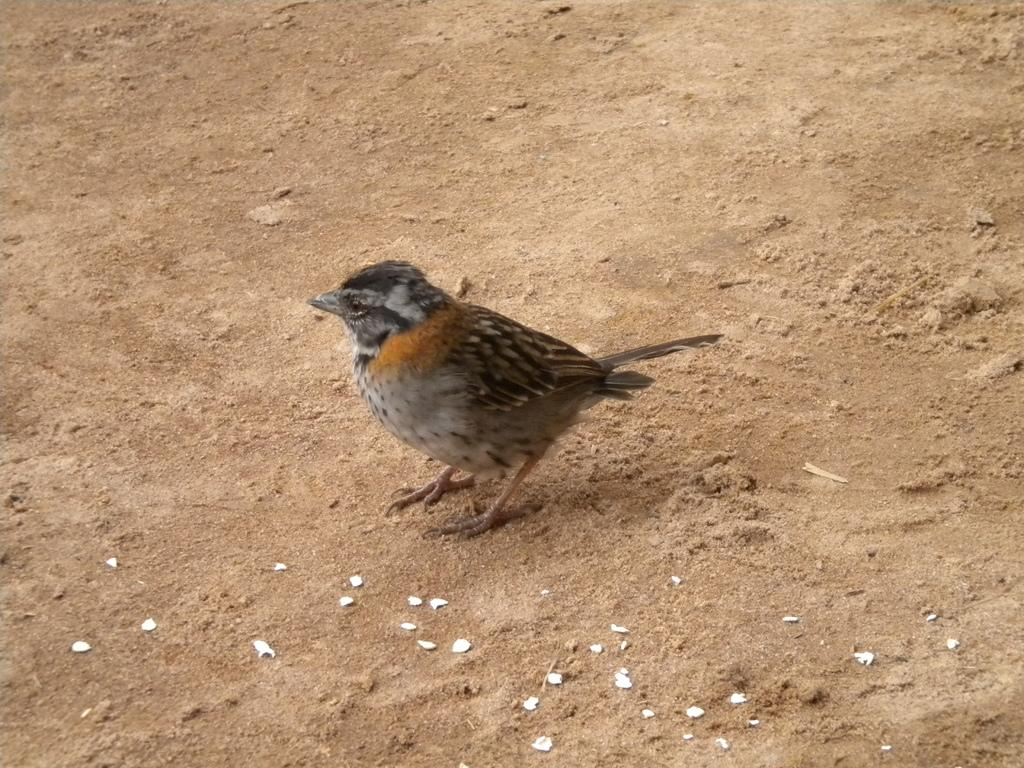What type of animal can be seen in the image? There is a bird in the image. Can you describe the objects on the ground in the image? Unfortunately, the facts provided do not give any details about the objects on the ground. What time of day is it in the image, and how does the paste help the men in the scene? There is no information about the time of day or any men in the image. Additionally, there is no mention of paste in the provided facts. 